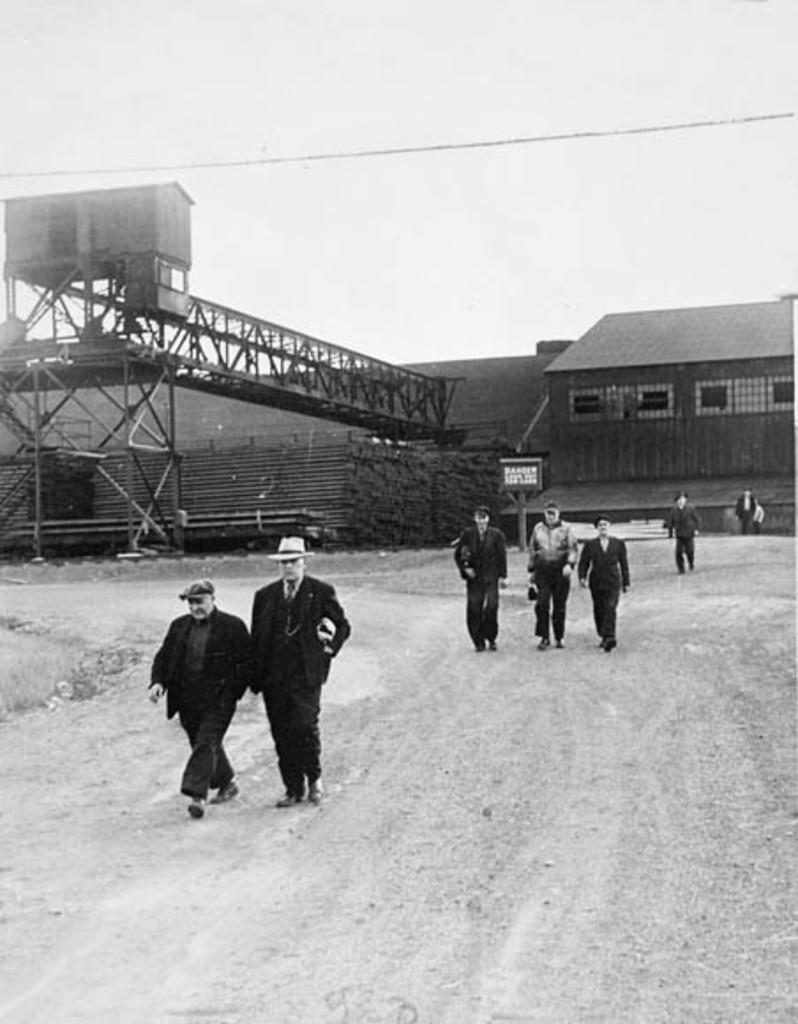Describe this image in one or two sentences. This image is a black and white image. This image is taken outdoors. At the top of the image there is the sky. At the bottom of the image there is a ground. In the background there is a building with walls, windows and a roof. There is a bridge. There are many iron bars. There is a fence and there is a board with a text on it. In the middle of the image a few people are walking on the ground. 